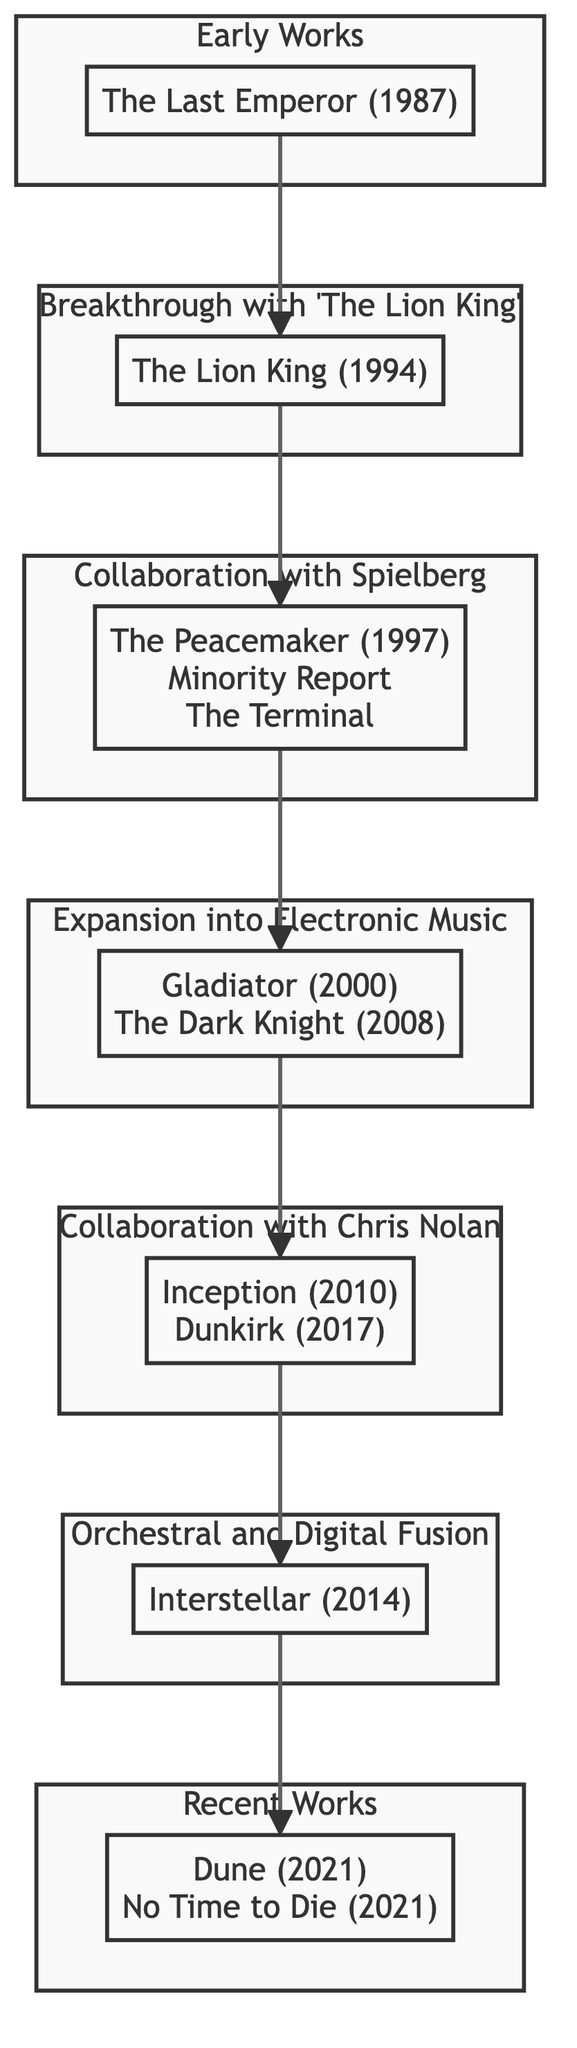What is the first album listed in Hans Zimmer's evolution? The diagram shows "The Last Emperor" (1987) as part of the Early Works subgraph, indicating it is the initial album in this chronology.
Answer: The Last Emperor (1987) How many collaborations are noted in the diagram? The diagram mentions two collaborations, one with Spielberg and another with Chris Nolan, making a total of two collaborations.
Answer: 2 What album signifies Hans Zimmer's breakthrough? The Breakthrough subgraph highlights "The Lion King" (1994) as the pivotal work that brought Zimmer significant recognition.
Answer: The Lion King (1994) What musical style is emphasized in 'Interstellar'? The Orchestral and Digital Fusion subgraph includes "Interstellar (2014)," which indicates this film showcases a blend of orchestral music and synthesizers, emphasizing a fusion of styles.
Answer: Orchestral and Digital Fusion Which two films are associated with the collaboration with Chris Nolan? The Collaboration with Chris Nolan subgraph lists "Inception (2010)" and "Dunkirk (2017)" as the two notable works, illustrating their partnership through these films.
Answer: Inception (2010), Dunkirk (2017) How does 'The Lion King' relate to Hans Zimmer's early works? The flow from Early Works to Breakthrough with 'The Lion King' shows that this album is a direct progression from his earliest compositions, marking a significant step in his career.
Answer: Breakthrough What element was integrated into scores like 'Gladiator' and 'The Dark Knight'? The Expansion into Electronic Music subgraph highlights that electronic elements were incorporated, indicating a shift in Zimmer’s artistic approach during this period.
Answer: Electronic elements What is the final category of musical evolution shown in the diagram? The Recent Works subgraph mentions "Dune (2021)" and "No Time to Die (2021)," indicating that these scores belong to the latest evolution of Hans Zimmer’s musical style.
Answer: Recent Works Which collaboration started with 'The Peacemaker'? The Collaboration with Spielberg subgraph indicates that this partnership began with "The Peacemaker (1997)," illustrating the first film they worked on together.
Answer: The Peacemaker (1997) 